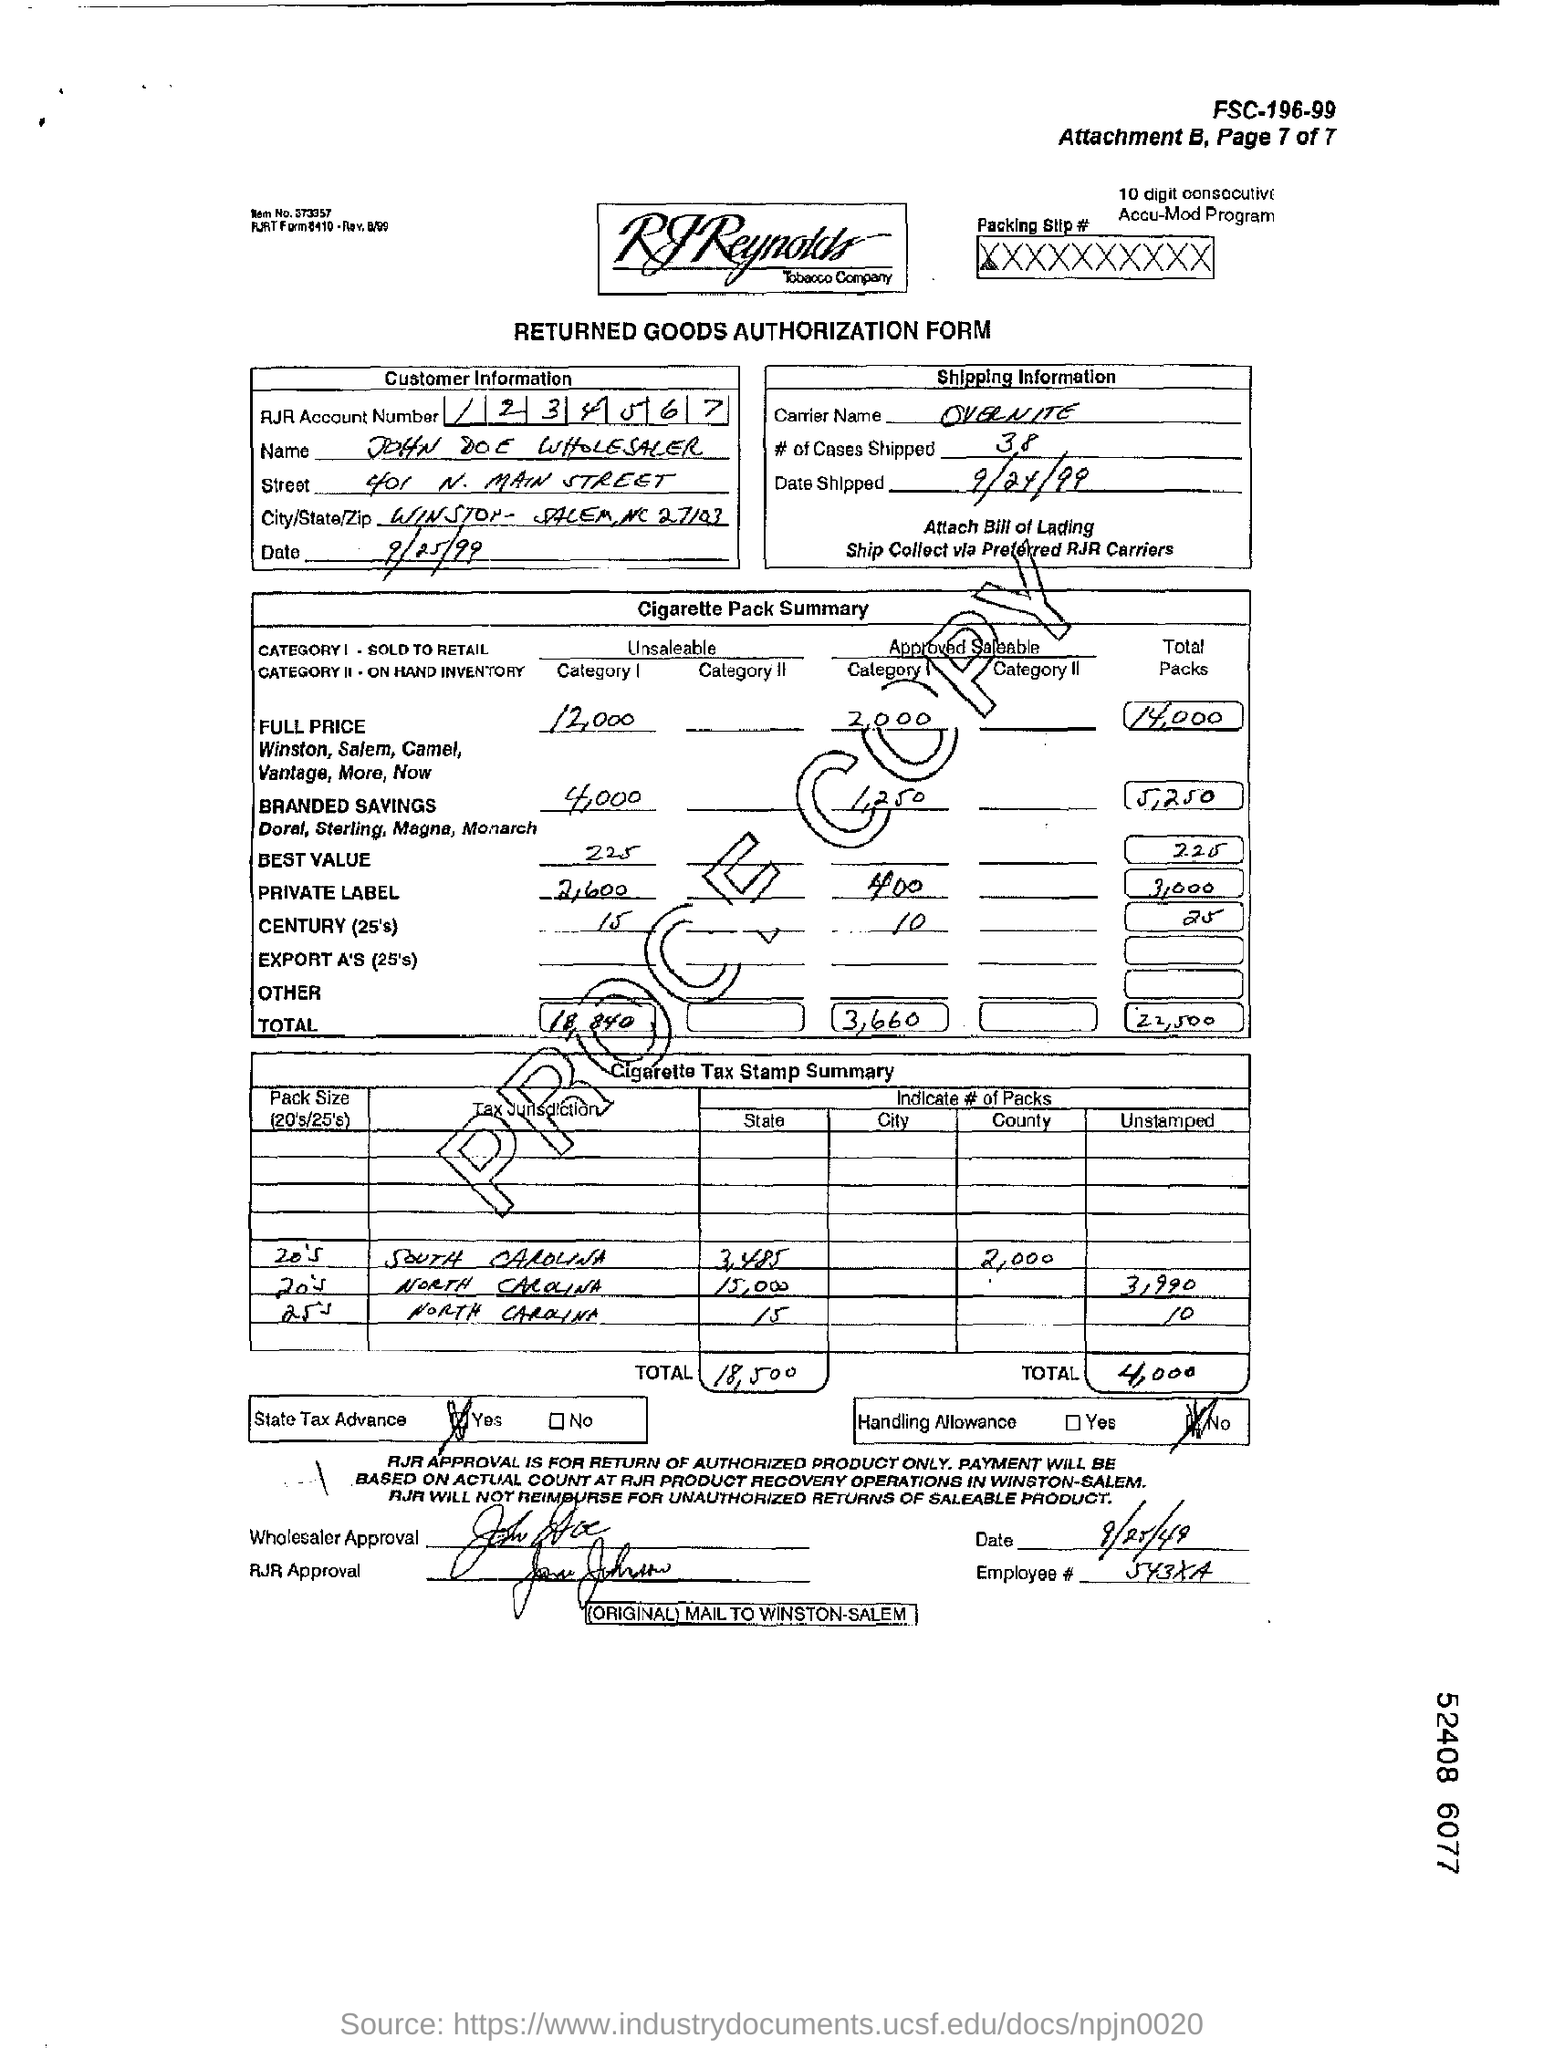Mention a couple of crucial points in this snapshot. Thirty-eight cases were shipped. The carrier's name is OVERNITE. The RJR account number mentioned is 1234567... 